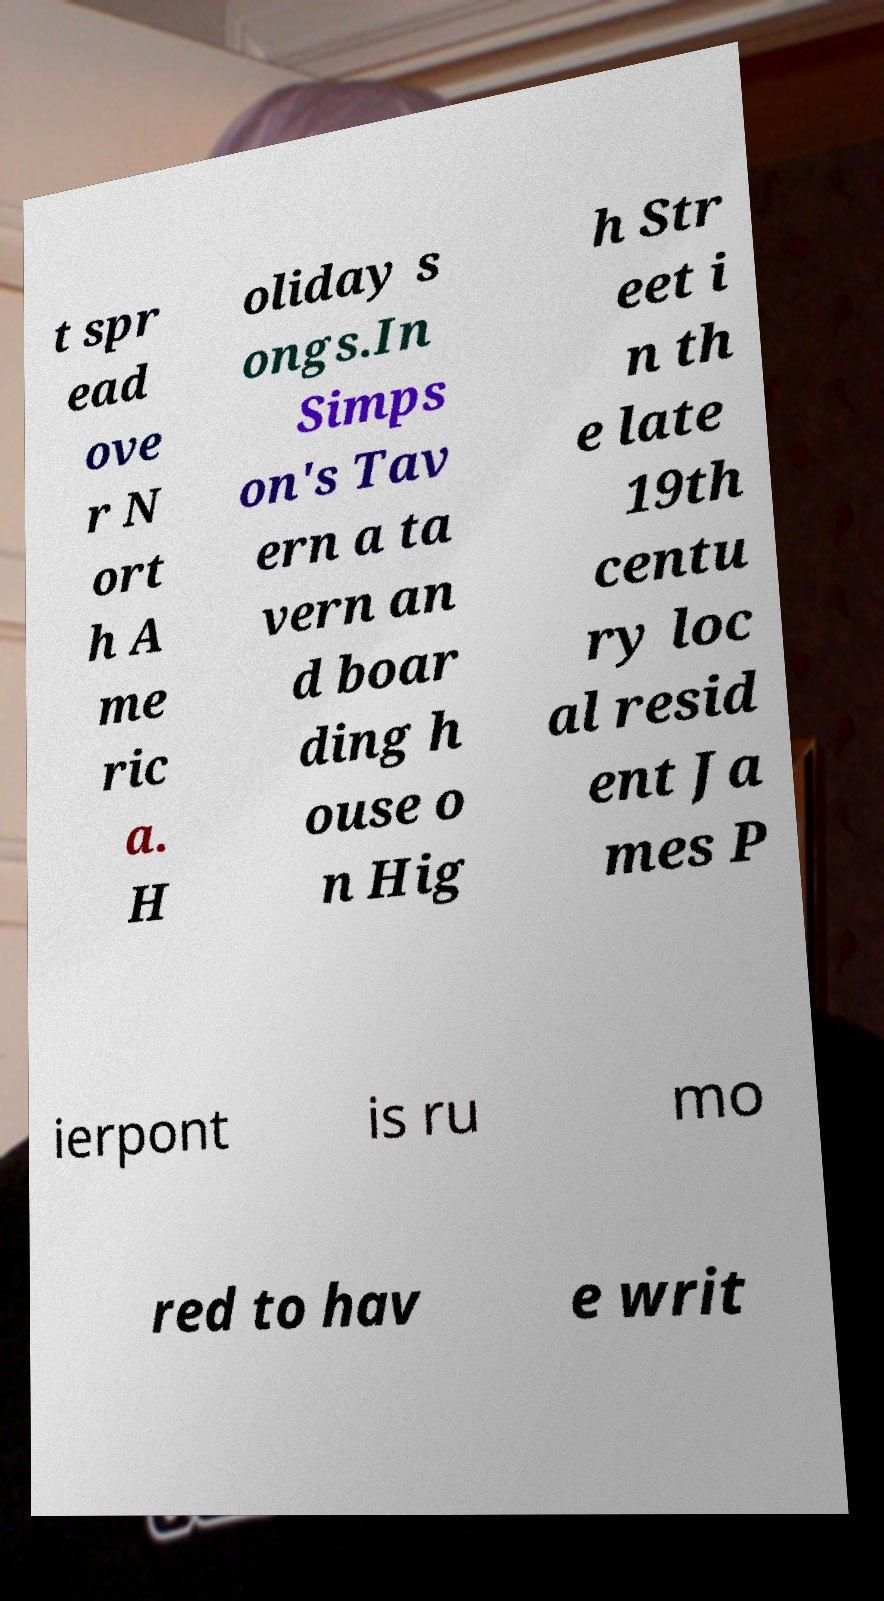Can you accurately transcribe the text from the provided image for me? t spr ead ove r N ort h A me ric a. H oliday s ongs.In Simps on's Tav ern a ta vern an d boar ding h ouse o n Hig h Str eet i n th e late 19th centu ry loc al resid ent Ja mes P ierpont is ru mo red to hav e writ 